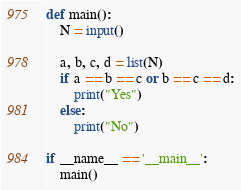<code> <loc_0><loc_0><loc_500><loc_500><_Python_>def main():
    N = input()

    a, b, c, d = list(N)
    if a == b == c or b == c == d:
        print("Yes")
    else:
        print("No")

if __name__ == '__main__':
    main()
</code> 